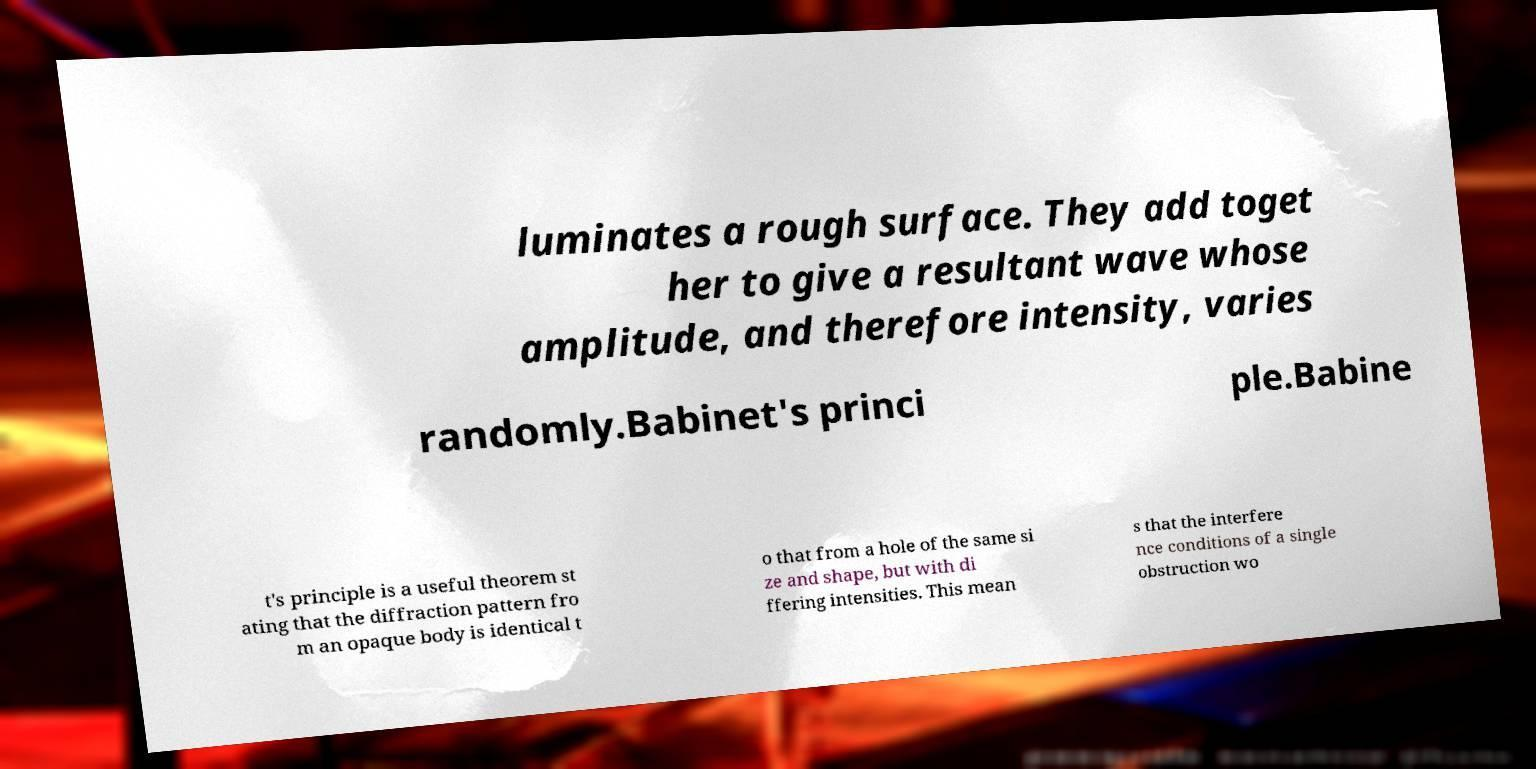Please identify and transcribe the text found in this image. luminates a rough surface. They add toget her to give a resultant wave whose amplitude, and therefore intensity, varies randomly.Babinet's princi ple.Babine t's principle is a useful theorem st ating that the diffraction pattern fro m an opaque body is identical t o that from a hole of the same si ze and shape, but with di ffering intensities. This mean s that the interfere nce conditions of a single obstruction wo 